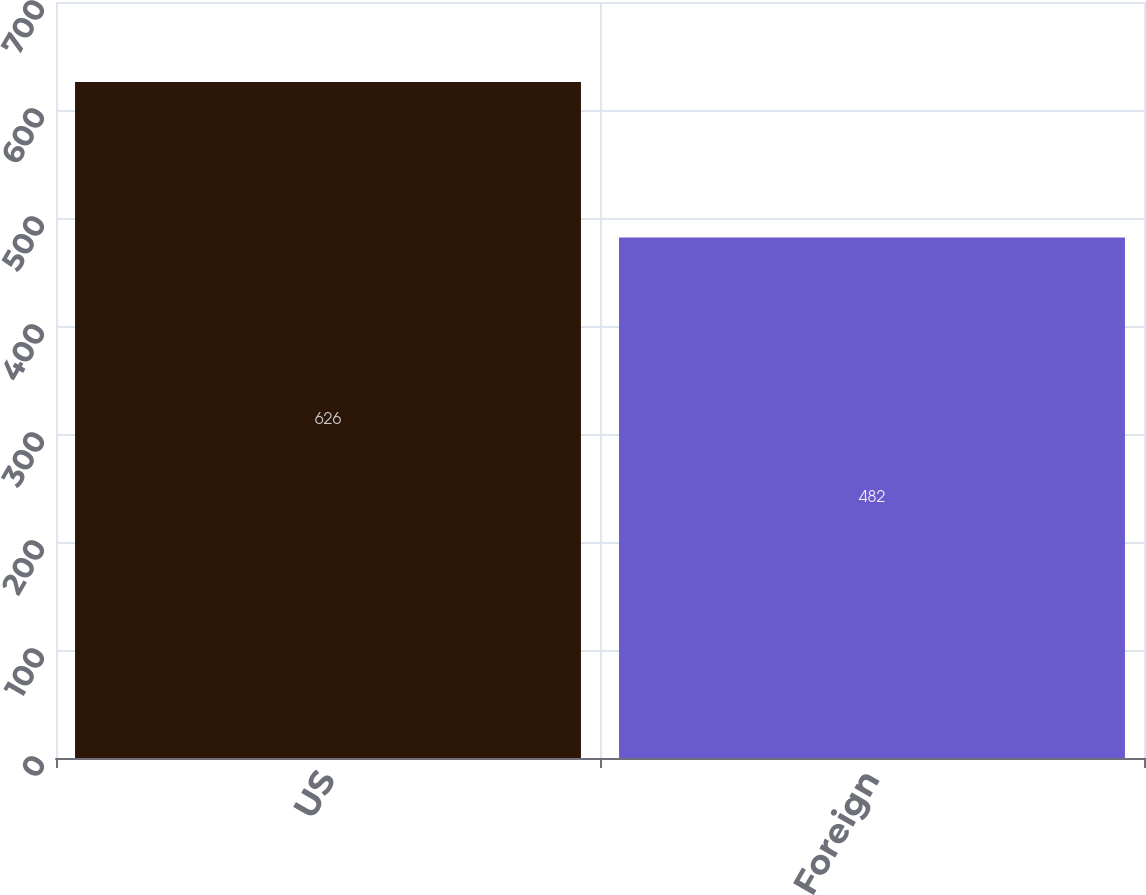<chart> <loc_0><loc_0><loc_500><loc_500><bar_chart><fcel>US<fcel>Foreign<nl><fcel>626<fcel>482<nl></chart> 